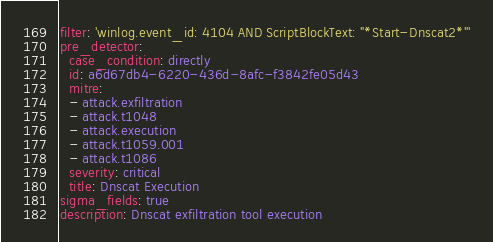<code> <loc_0><loc_0><loc_500><loc_500><_YAML_>filter: 'winlog.event_id: 4104 AND ScriptBlockText: "*Start-Dnscat2*"'
pre_detector:
  case_condition: directly
  id: a6d67db4-6220-436d-8afc-f3842fe05d43
  mitre:
  - attack.exfiltration
  - attack.t1048
  - attack.execution
  - attack.t1059.001
  - attack.t1086
  severity: critical
  title: Dnscat Execution
sigma_fields: true
description: Dnscat exfiltration tool execution</code> 